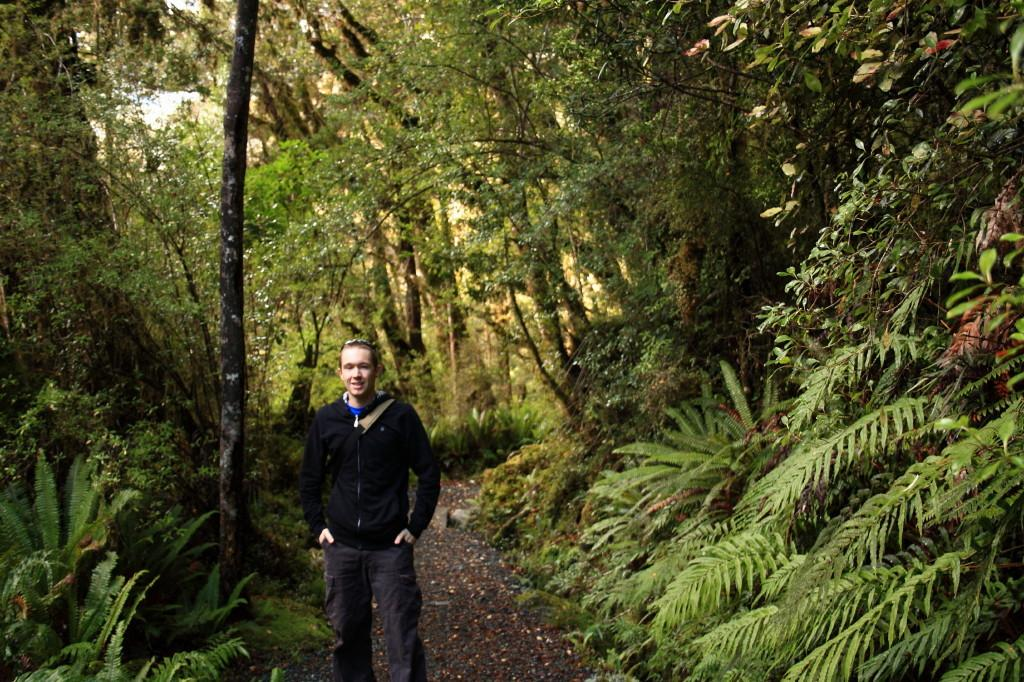What is the main subject of the image? There is a person in the image. What is the person wearing? The person is wearing a black jacket. Where is the person standing? The person is standing on a path. What can be seen in the background of the image? There are plants and trees in the background of the image. Can you see a crow flying over the person's head in the image? There is no crow visible in the image. Is the person in the image a spy? There is no information in the image to suggest that the person is a spy. 